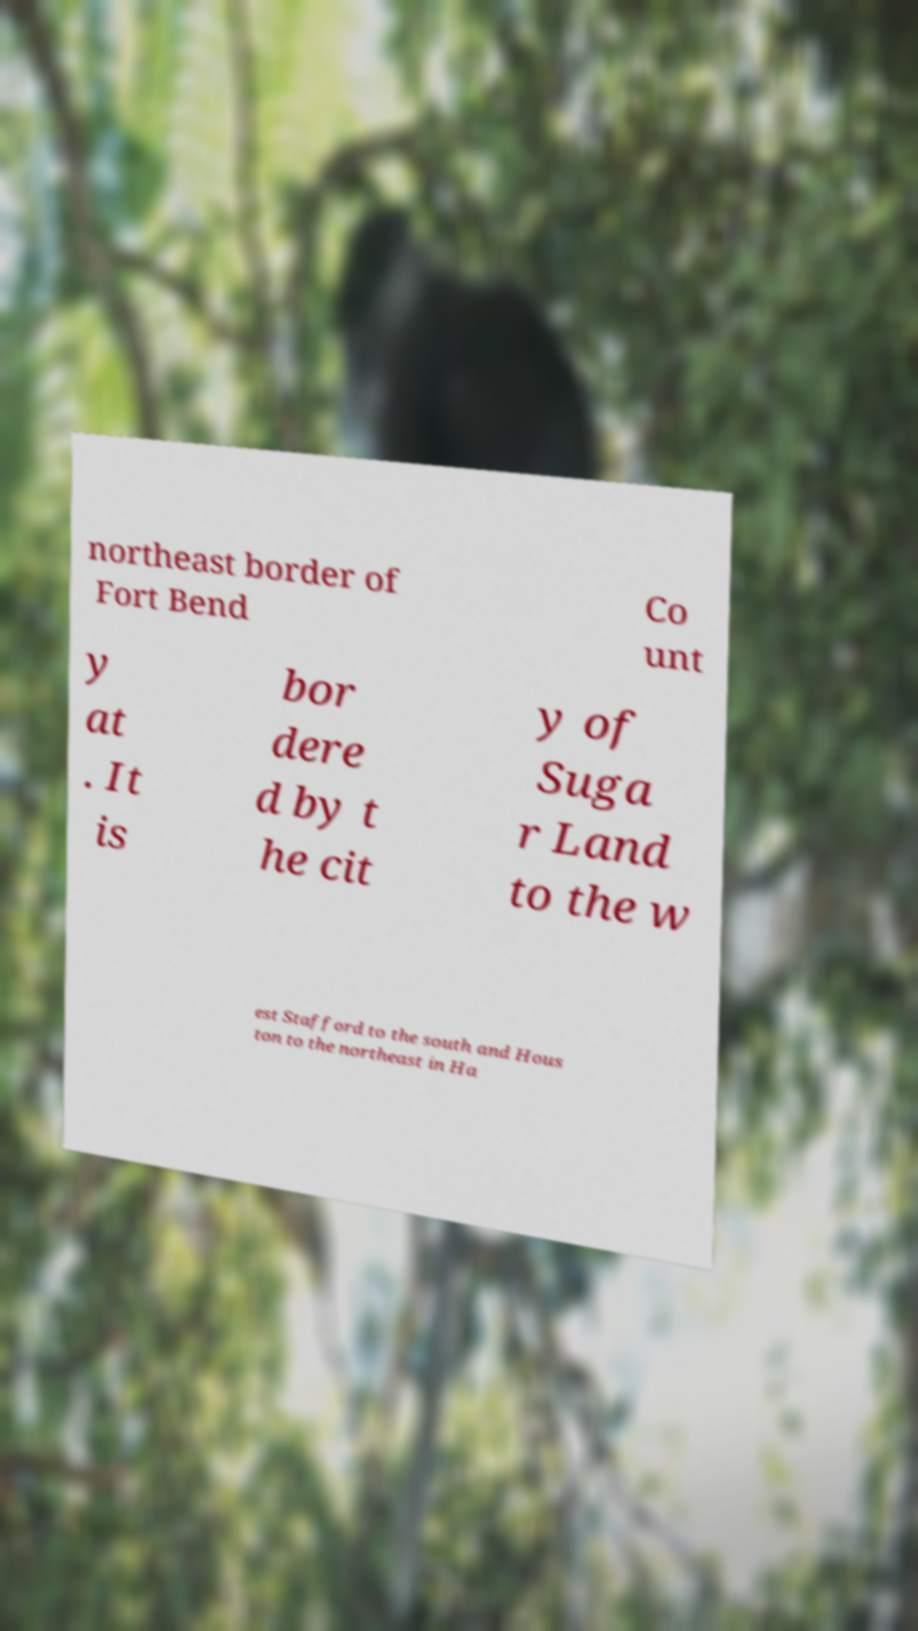Could you assist in decoding the text presented in this image and type it out clearly? northeast border of Fort Bend Co unt y at . It is bor dere d by t he cit y of Suga r Land to the w est Stafford to the south and Hous ton to the northeast in Ha 